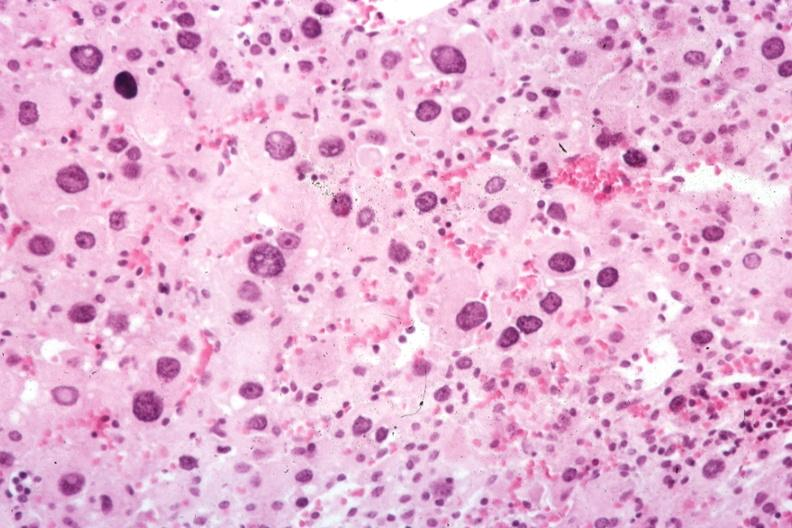does this image show typical cells?
Answer the question using a single word or phrase. Yes 